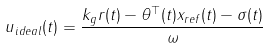Convert formula to latex. <formula><loc_0><loc_0><loc_500><loc_500>u _ { i d e a l } ( t ) = \frac { k _ { g } r ( t ) - \theta ^ { \top } ( t ) x _ { r e f } ( t ) - \sigma ( t ) } { \omega }</formula> 